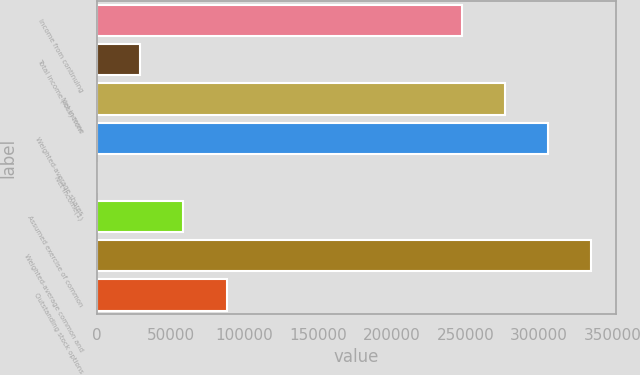<chart> <loc_0><loc_0><loc_500><loc_500><bar_chart><fcel>Income from continuing<fcel>Total income (loss) from<fcel>Net income<fcel>Weighted-average shares<fcel>Net income(1)<fcel>Assumed exercise of common<fcel>Weighted-average common and<fcel>Outstanding stock options<nl><fcel>247408<fcel>29270.6<fcel>276678<fcel>305947<fcel>0.85<fcel>58540.3<fcel>335217<fcel>87810<nl></chart> 